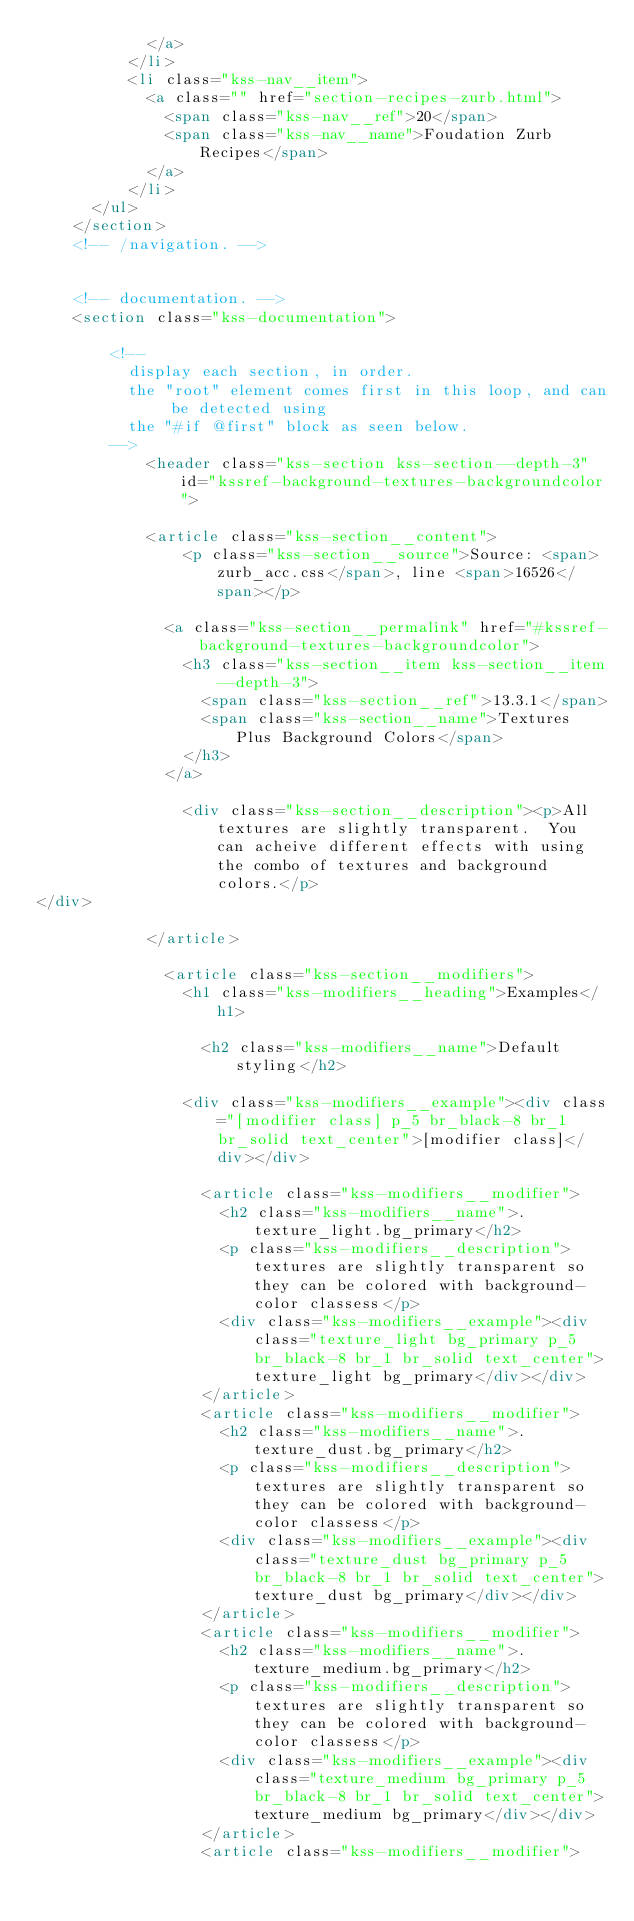<code> <loc_0><loc_0><loc_500><loc_500><_HTML_>            </a>
          </li>
          <li class="kss-nav__item">
            <a class="" href="section-recipes-zurb.html">
              <span class="kss-nav__ref">20</span>
              <span class="kss-nav__name">Foudation Zurb Recipes</span>
            </a>
          </li>
      </ul>
    </section>
    <!-- /navigation. -->


    <!-- documentation. -->
    <section class="kss-documentation">

        <!--
          display each section, in order.
          the "root" element comes first in this loop, and can be detected using
          the "#if @first" block as seen below.
        -->
            <header class="kss-section kss-section--depth-3" id="kssref-background-textures-backgroundcolor">

            <article class="kss-section__content">
                <p class="kss-section__source">Source: <span>zurb_acc.css</span>, line <span>16526</span></p>

              <a class="kss-section__permalink" href="#kssref-background-textures-backgroundcolor">
                <h3 class="kss-section__item kss-section__item--depth-3">
                  <span class="kss-section__ref">13.3.1</span>
                  <span class="kss-section__name">Textures Plus Background Colors</span>
                </h3>
              </a>

                <div class="kss-section__description"><p>All textures are slightly transparent.  You can acheive different effects with using the combo of textures and background colors.</p>
</div>

            </article>

              <article class="kss-section__modifiers">
                <h1 class="kss-modifiers__heading">Examples</h1>

                  <h2 class="kss-modifiers__name">Default styling</h2>

                <div class="kss-modifiers__example"><div class="[modifier class] p_5 br_black-8 br_1 br_solid text_center">[modifier class]</div></div>

                  <article class="kss-modifiers__modifier">
                    <h2 class="kss-modifiers__name">.texture_light.bg_primary</h2>
                    <p class="kss-modifiers__description">textures are slightly transparent so they can be colored with background-color classess</p>
                    <div class="kss-modifiers__example"><div class="texture_light bg_primary p_5 br_black-8 br_1 br_solid text_center">texture_light bg_primary</div></div>
                  </article>
                  <article class="kss-modifiers__modifier">
                    <h2 class="kss-modifiers__name">.texture_dust.bg_primary</h2>
                    <p class="kss-modifiers__description">textures are slightly transparent so they can be colored with background-color classess</p>
                    <div class="kss-modifiers__example"><div class="texture_dust bg_primary p_5 br_black-8 br_1 br_solid text_center">texture_dust bg_primary</div></div>
                  </article>
                  <article class="kss-modifiers__modifier">
                    <h2 class="kss-modifiers__name">.texture_medium.bg_primary</h2>
                    <p class="kss-modifiers__description">textures are slightly transparent so they can be colored with background-color classess</p>
                    <div class="kss-modifiers__example"><div class="texture_medium bg_primary p_5 br_black-8 br_1 br_solid text_center">texture_medium bg_primary</div></div>
                  </article>
                  <article class="kss-modifiers__modifier"></code> 